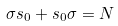Convert formula to latex. <formula><loc_0><loc_0><loc_500><loc_500>\sigma { s } _ { 0 } + { s } _ { 0 } \sigma = N</formula> 